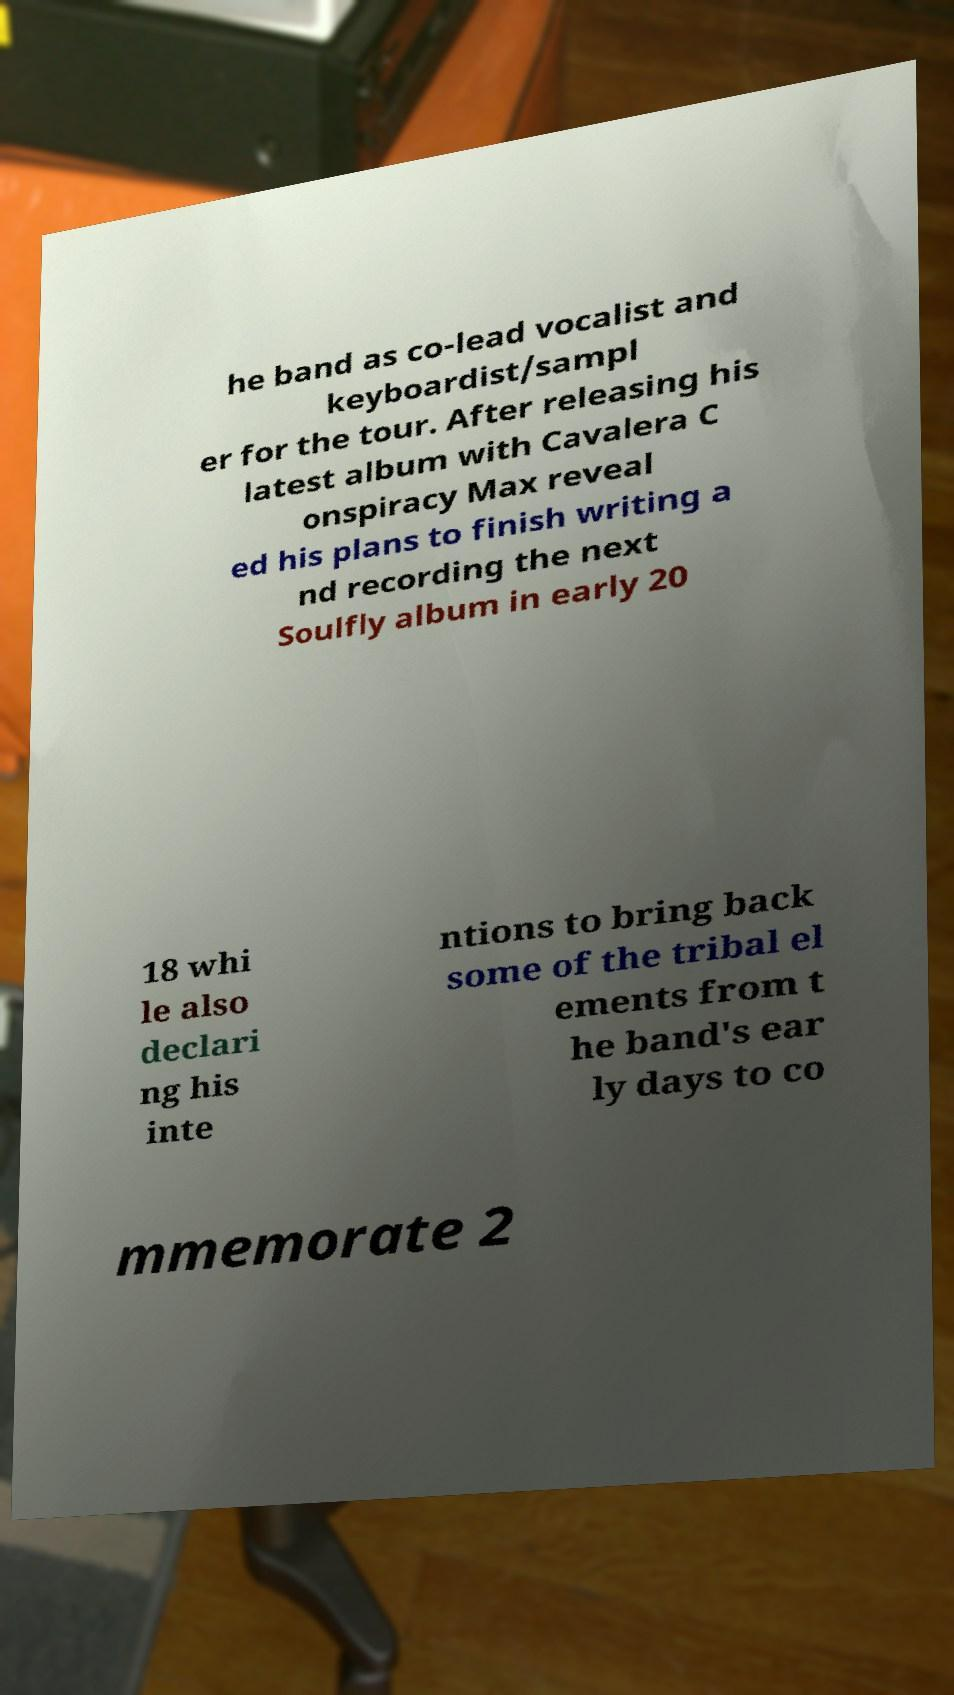For documentation purposes, I need the text within this image transcribed. Could you provide that? he band as co-lead vocalist and keyboardist/sampl er for the tour. After releasing his latest album with Cavalera C onspiracy Max reveal ed his plans to finish writing a nd recording the next Soulfly album in early 20 18 whi le also declari ng his inte ntions to bring back some of the tribal el ements from t he band's ear ly days to co mmemorate 2 